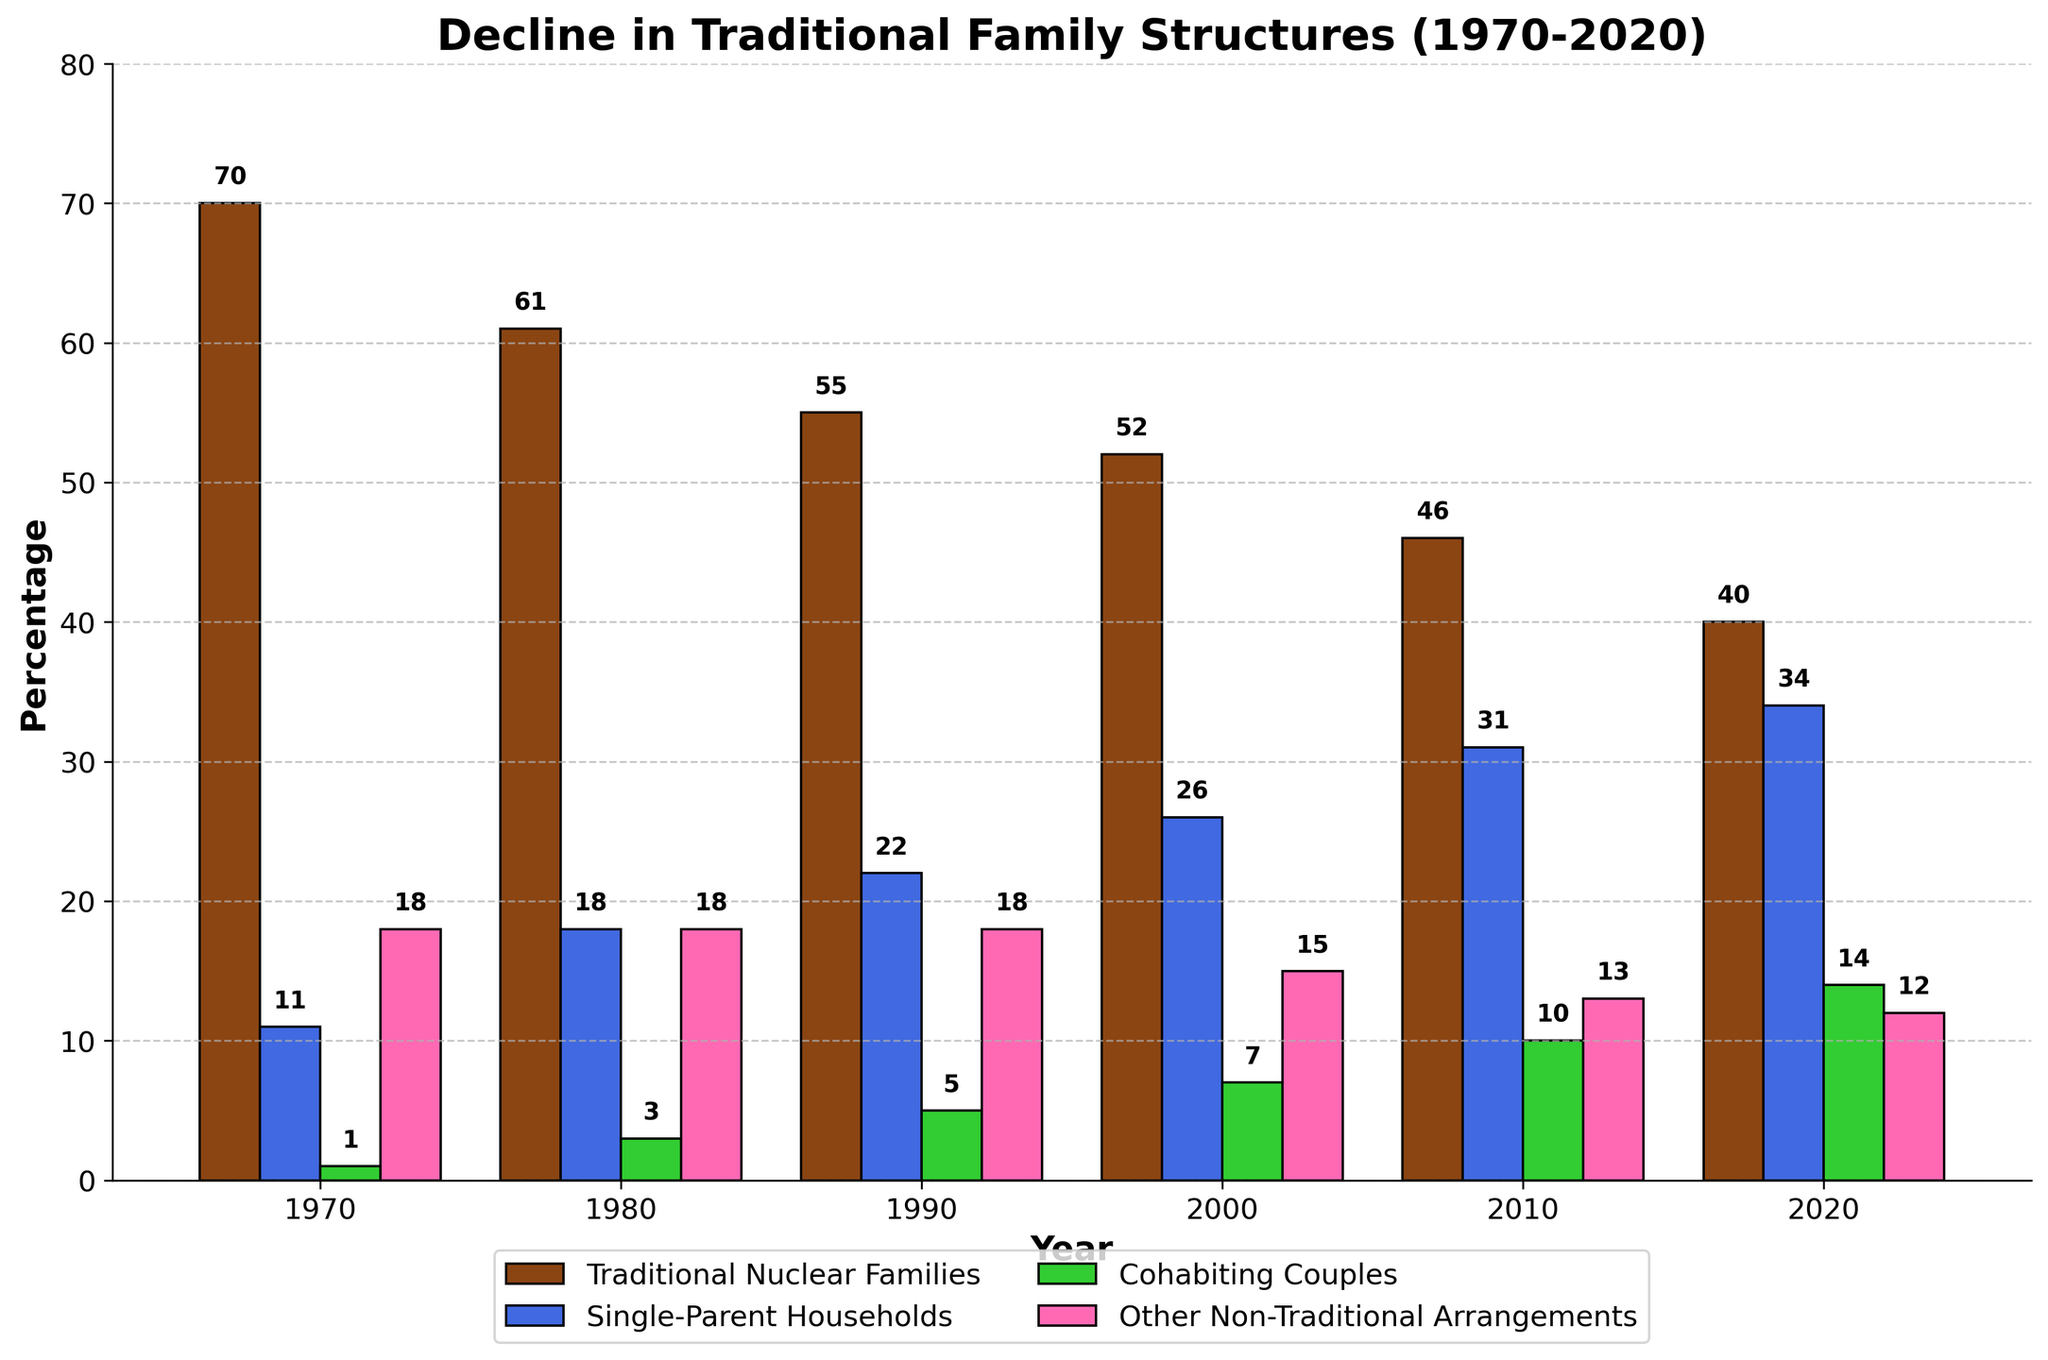What year shows the lowest percentage of Traditional Nuclear Families? By observing the bars representing Traditional Nuclear Families, we notice that the height of the bar for 2020 is the lowest among all years
Answer: 2020 What is the approximate total percentage of non-traditional families (Single-Parent Households, Cohabiting Couples, Other Non-Traditional Arrangements) in 2010? To find the total percentage, sum up the heights of the bars representing Single-Parent Households, Cohabiting Couples, and Other Non-Traditional Arrangements for the year 2010 (31 + 10 + 13)
Answer: 54 Which year has the highest percentage of Cohabiting Couples? By comparing the heights of the green bars across all years, the 2020 bar has the highest value for Cohabiting Couples
Answer: 2020 Compare the percentage of Single-Parent Households between 1980 and 1990. Which year is higher? Compare the heights of the blue bars for the years 1980 and 1990. The bar for 1990 is higher than that for 1980
Answer: 1990 How many years show a decline in Traditional Nuclear Families? Observe the brown bars for each year. Count the years where the percentage of Traditional Nuclear Families is lower than the previous year. The percentage declines in every successive year
Answer: 5 What is the percentage difference between Traditional Nuclear Families and Single-Parent Households in 1970? Subtract the percentage of Single-Parent Households from that of Traditional Nuclear Families for the year 1970 (70 - 11)
Answer: 59 Which arrangement shows the least variation in percentage over the years? Compare the bars' heights for each arrangement over the years. The 'Other Non-Traditional Arrangements' bars show the smallest changes and maintain around 18%
Answer: Other Non-Traditional Arrangements Identify the years where the percentage of Traditional Nuclear Families fell below 50%. Look for the years where the height of the brown bar for Traditional Nuclear Families is below the 50% line. These years are 2010 and 2020
Answer: 2010, 2020 What is the percentage of Traditional Nuclear Families in 1980 compared to 2020? Compare the heights of the brown bars for the years 1980 and 2020. The percentage in 1980 is 61%, and in 2020 it is 40%
Answer: 61%, 40% Between 1990 and 2000, which category of family arrangement saw the most significant increase? Compare the increases in bar heights between 1990 and 2000 for each category. The Single-Parent Households category saw the most significant increase from 22% to 26%
Answer: Single-Parent Households 